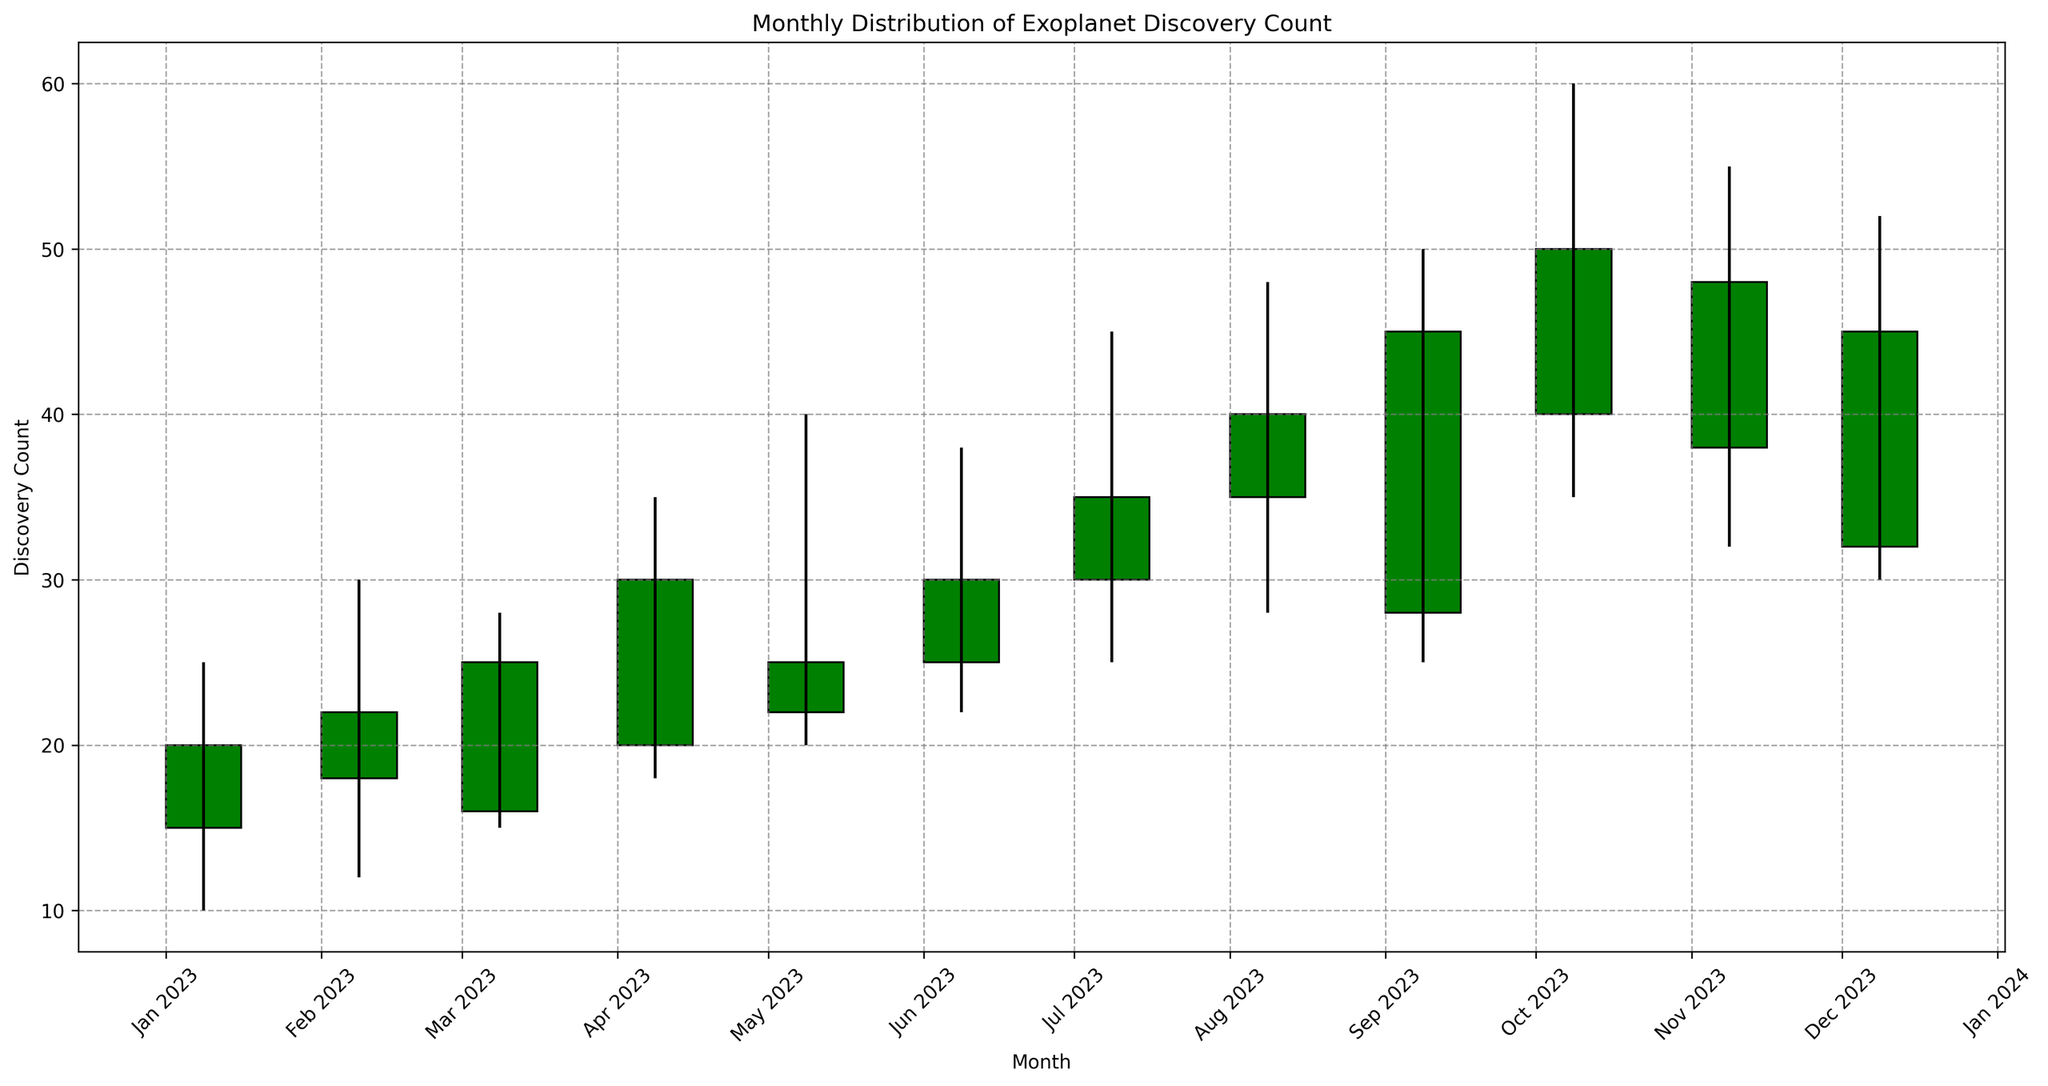Which month had the highest exoplanet discovery count? Look at the 'High' values on the candlestick chart and find the month with the highest peak. The highest value is 60 in October 2023.
Answer: October 2023 During which months did the closing discovery count exceed the opening count? Identify months where the closing price is higher than the opening price by comparing the open and close values visually, which are represented by the bottom and top of the candlestick body when it's green.
Answer: January, February, March, April, June, July, August, October, November What is the average high value across all months? To find the average, sum up all high values and divide by the number of months. The sum is 25+30+28+35+40+38+45+48+50+60+55+52 = 506, and there are 12 months, so 506/12 = 42.17.
Answer: 42.17 Which month shows the greatest volatility in discovery count? Volatility can be observed by the length of the wicks (lines) extending from the body of the candlestick. The month with the longest vertical line is October, with a range from a low of 35 to a high of 60, a span of 25 units.
Answer: October 2023 Which months had a decrease in the discovery count from open to close? Identify months where the opening price is higher than the closing price by comparing the open and close values visually, which are represented by the bottom and top of the candlestick body when it's red.
Answer: May, September, December Compare the overall trend from July to December. Did the discovery count generally increase, decrease, or stay the same? Observe the candlestick bodies from July to December. The trend indicates an increase as the closing values generally rise from July (35) to December (45).
Answer: Increase What is the difference between the highest 'High' value and the lowest 'Low' value in the data? The highest 'High' value is 60 (October), and the lowest 'Low' value is 10 (January). The difference is 60 - 10 = 50.
Answer: 50 For how many months did the 'Close' value surpass the 'High' value of the previous month? Compare the 'Close' value of each month with the 'High' of the previous month. In January, February, March, May, July, August, September, October, and November, the 'Close' value surpasses the previous month's 'High'.
Answer: 9 In which month did the exoplanet discovery count have the smallest range? The range is determined by the difference between the 'High' and 'Low' values in each month. The smallest range is for March with a difference of 13 (28 - 15), followed by the ranges 15, 18, etc.
Answer: March 2023 